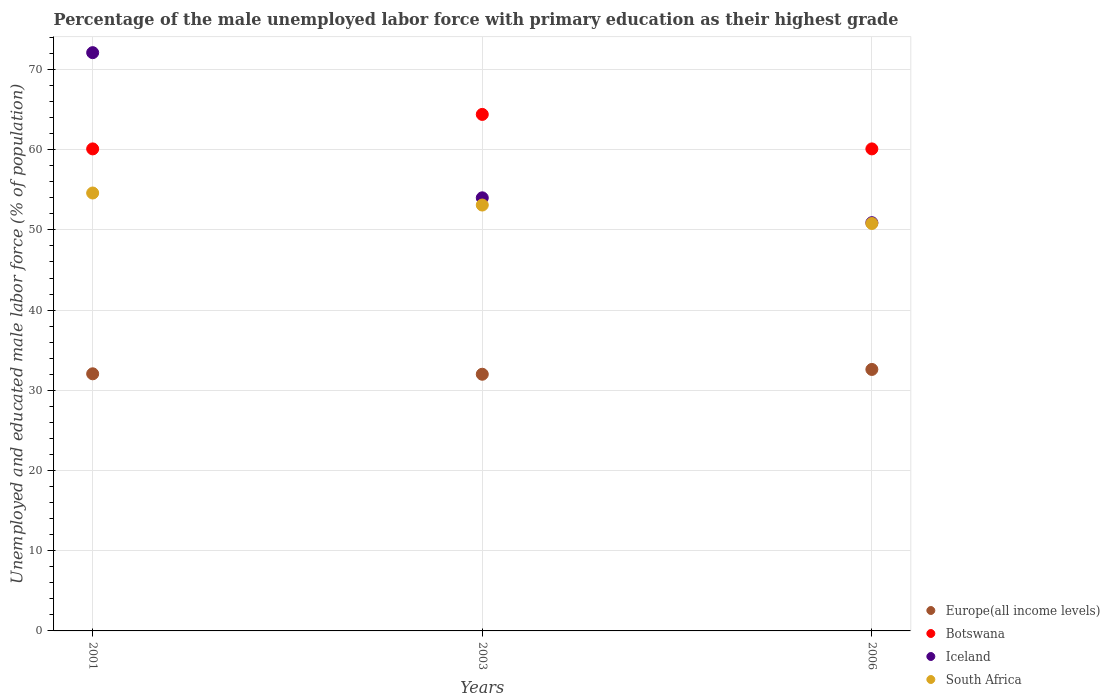How many different coloured dotlines are there?
Your answer should be very brief. 4. Is the number of dotlines equal to the number of legend labels?
Keep it short and to the point. Yes. What is the percentage of the unemployed male labor force with primary education in Botswana in 2001?
Keep it short and to the point. 60.1. Across all years, what is the maximum percentage of the unemployed male labor force with primary education in Botswana?
Give a very brief answer. 64.4. Across all years, what is the minimum percentage of the unemployed male labor force with primary education in South Africa?
Your response must be concise. 50.8. In which year was the percentage of the unemployed male labor force with primary education in South Africa maximum?
Provide a succinct answer. 2001. In which year was the percentage of the unemployed male labor force with primary education in Botswana minimum?
Your response must be concise. 2001. What is the total percentage of the unemployed male labor force with primary education in Europe(all income levels) in the graph?
Make the answer very short. 96.66. What is the difference between the percentage of the unemployed male labor force with primary education in Botswana in 2003 and that in 2006?
Make the answer very short. 4.3. What is the average percentage of the unemployed male labor force with primary education in Iceland per year?
Your response must be concise. 59. In the year 2006, what is the difference between the percentage of the unemployed male labor force with primary education in Botswana and percentage of the unemployed male labor force with primary education in Europe(all income levels)?
Provide a succinct answer. 27.5. In how many years, is the percentage of the unemployed male labor force with primary education in Europe(all income levels) greater than 32 %?
Provide a short and direct response. 3. What is the ratio of the percentage of the unemployed male labor force with primary education in South Africa in 2003 to that in 2006?
Your response must be concise. 1.05. What is the difference between the highest and the second highest percentage of the unemployed male labor force with primary education in Botswana?
Offer a terse response. 4.3. What is the difference between the highest and the lowest percentage of the unemployed male labor force with primary education in Europe(all income levels)?
Your answer should be compact. 0.6. Is the sum of the percentage of the unemployed male labor force with primary education in Botswana in 2001 and 2003 greater than the maximum percentage of the unemployed male labor force with primary education in Iceland across all years?
Your response must be concise. Yes. Is it the case that in every year, the sum of the percentage of the unemployed male labor force with primary education in Botswana and percentage of the unemployed male labor force with primary education in Iceland  is greater than the percentage of the unemployed male labor force with primary education in South Africa?
Your response must be concise. Yes. Is the percentage of the unemployed male labor force with primary education in Iceland strictly greater than the percentage of the unemployed male labor force with primary education in Europe(all income levels) over the years?
Offer a very short reply. Yes. Is the percentage of the unemployed male labor force with primary education in Iceland strictly less than the percentage of the unemployed male labor force with primary education in Botswana over the years?
Provide a short and direct response. No. How many dotlines are there?
Make the answer very short. 4. How many years are there in the graph?
Give a very brief answer. 3. What is the difference between two consecutive major ticks on the Y-axis?
Offer a terse response. 10. Are the values on the major ticks of Y-axis written in scientific E-notation?
Give a very brief answer. No. Does the graph contain grids?
Provide a short and direct response. Yes. Where does the legend appear in the graph?
Ensure brevity in your answer.  Bottom right. How many legend labels are there?
Keep it short and to the point. 4. How are the legend labels stacked?
Your response must be concise. Vertical. What is the title of the graph?
Keep it short and to the point. Percentage of the male unemployed labor force with primary education as their highest grade. What is the label or title of the X-axis?
Make the answer very short. Years. What is the label or title of the Y-axis?
Keep it short and to the point. Unemployed and educated male labor force (% of population). What is the Unemployed and educated male labor force (% of population) in Europe(all income levels) in 2001?
Provide a succinct answer. 32.06. What is the Unemployed and educated male labor force (% of population) in Botswana in 2001?
Your answer should be very brief. 60.1. What is the Unemployed and educated male labor force (% of population) of Iceland in 2001?
Give a very brief answer. 72.1. What is the Unemployed and educated male labor force (% of population) of South Africa in 2001?
Your response must be concise. 54.6. What is the Unemployed and educated male labor force (% of population) of Europe(all income levels) in 2003?
Your answer should be compact. 32. What is the Unemployed and educated male labor force (% of population) in Botswana in 2003?
Offer a very short reply. 64.4. What is the Unemployed and educated male labor force (% of population) of South Africa in 2003?
Your response must be concise. 53.1. What is the Unemployed and educated male labor force (% of population) of Europe(all income levels) in 2006?
Your response must be concise. 32.6. What is the Unemployed and educated male labor force (% of population) of Botswana in 2006?
Keep it short and to the point. 60.1. What is the Unemployed and educated male labor force (% of population) in Iceland in 2006?
Provide a succinct answer. 50.9. What is the Unemployed and educated male labor force (% of population) in South Africa in 2006?
Keep it short and to the point. 50.8. Across all years, what is the maximum Unemployed and educated male labor force (% of population) in Europe(all income levels)?
Provide a short and direct response. 32.6. Across all years, what is the maximum Unemployed and educated male labor force (% of population) of Botswana?
Provide a short and direct response. 64.4. Across all years, what is the maximum Unemployed and educated male labor force (% of population) in Iceland?
Your answer should be very brief. 72.1. Across all years, what is the maximum Unemployed and educated male labor force (% of population) in South Africa?
Keep it short and to the point. 54.6. Across all years, what is the minimum Unemployed and educated male labor force (% of population) in Europe(all income levels)?
Make the answer very short. 32. Across all years, what is the minimum Unemployed and educated male labor force (% of population) of Botswana?
Your response must be concise. 60.1. Across all years, what is the minimum Unemployed and educated male labor force (% of population) of Iceland?
Make the answer very short. 50.9. Across all years, what is the minimum Unemployed and educated male labor force (% of population) in South Africa?
Offer a terse response. 50.8. What is the total Unemployed and educated male labor force (% of population) of Europe(all income levels) in the graph?
Your answer should be compact. 96.66. What is the total Unemployed and educated male labor force (% of population) of Botswana in the graph?
Give a very brief answer. 184.6. What is the total Unemployed and educated male labor force (% of population) in Iceland in the graph?
Your response must be concise. 177. What is the total Unemployed and educated male labor force (% of population) in South Africa in the graph?
Give a very brief answer. 158.5. What is the difference between the Unemployed and educated male labor force (% of population) of Europe(all income levels) in 2001 and that in 2003?
Ensure brevity in your answer.  0.06. What is the difference between the Unemployed and educated male labor force (% of population) in Iceland in 2001 and that in 2003?
Provide a short and direct response. 18.1. What is the difference between the Unemployed and educated male labor force (% of population) of South Africa in 2001 and that in 2003?
Offer a very short reply. 1.5. What is the difference between the Unemployed and educated male labor force (% of population) in Europe(all income levels) in 2001 and that in 2006?
Give a very brief answer. -0.54. What is the difference between the Unemployed and educated male labor force (% of population) of Botswana in 2001 and that in 2006?
Offer a terse response. 0. What is the difference between the Unemployed and educated male labor force (% of population) in Iceland in 2001 and that in 2006?
Offer a terse response. 21.2. What is the difference between the Unemployed and educated male labor force (% of population) in Europe(all income levels) in 2003 and that in 2006?
Ensure brevity in your answer.  -0.6. What is the difference between the Unemployed and educated male labor force (% of population) of Botswana in 2003 and that in 2006?
Offer a very short reply. 4.3. What is the difference between the Unemployed and educated male labor force (% of population) in South Africa in 2003 and that in 2006?
Give a very brief answer. 2.3. What is the difference between the Unemployed and educated male labor force (% of population) of Europe(all income levels) in 2001 and the Unemployed and educated male labor force (% of population) of Botswana in 2003?
Your response must be concise. -32.34. What is the difference between the Unemployed and educated male labor force (% of population) of Europe(all income levels) in 2001 and the Unemployed and educated male labor force (% of population) of Iceland in 2003?
Offer a very short reply. -21.94. What is the difference between the Unemployed and educated male labor force (% of population) of Europe(all income levels) in 2001 and the Unemployed and educated male labor force (% of population) of South Africa in 2003?
Give a very brief answer. -21.04. What is the difference between the Unemployed and educated male labor force (% of population) in Botswana in 2001 and the Unemployed and educated male labor force (% of population) in Iceland in 2003?
Your answer should be compact. 6.1. What is the difference between the Unemployed and educated male labor force (% of population) of Iceland in 2001 and the Unemployed and educated male labor force (% of population) of South Africa in 2003?
Keep it short and to the point. 19. What is the difference between the Unemployed and educated male labor force (% of population) in Europe(all income levels) in 2001 and the Unemployed and educated male labor force (% of population) in Botswana in 2006?
Give a very brief answer. -28.04. What is the difference between the Unemployed and educated male labor force (% of population) in Europe(all income levels) in 2001 and the Unemployed and educated male labor force (% of population) in Iceland in 2006?
Ensure brevity in your answer.  -18.84. What is the difference between the Unemployed and educated male labor force (% of population) of Europe(all income levels) in 2001 and the Unemployed and educated male labor force (% of population) of South Africa in 2006?
Give a very brief answer. -18.74. What is the difference between the Unemployed and educated male labor force (% of population) in Iceland in 2001 and the Unemployed and educated male labor force (% of population) in South Africa in 2006?
Your answer should be compact. 21.3. What is the difference between the Unemployed and educated male labor force (% of population) in Europe(all income levels) in 2003 and the Unemployed and educated male labor force (% of population) in Botswana in 2006?
Your answer should be very brief. -28.1. What is the difference between the Unemployed and educated male labor force (% of population) in Europe(all income levels) in 2003 and the Unemployed and educated male labor force (% of population) in Iceland in 2006?
Keep it short and to the point. -18.9. What is the difference between the Unemployed and educated male labor force (% of population) of Europe(all income levels) in 2003 and the Unemployed and educated male labor force (% of population) of South Africa in 2006?
Give a very brief answer. -18.8. What is the difference between the Unemployed and educated male labor force (% of population) of Iceland in 2003 and the Unemployed and educated male labor force (% of population) of South Africa in 2006?
Give a very brief answer. 3.2. What is the average Unemployed and educated male labor force (% of population) of Europe(all income levels) per year?
Offer a very short reply. 32.22. What is the average Unemployed and educated male labor force (% of population) of Botswana per year?
Offer a terse response. 61.53. What is the average Unemployed and educated male labor force (% of population) in South Africa per year?
Ensure brevity in your answer.  52.83. In the year 2001, what is the difference between the Unemployed and educated male labor force (% of population) in Europe(all income levels) and Unemployed and educated male labor force (% of population) in Botswana?
Give a very brief answer. -28.04. In the year 2001, what is the difference between the Unemployed and educated male labor force (% of population) of Europe(all income levels) and Unemployed and educated male labor force (% of population) of Iceland?
Your answer should be compact. -40.04. In the year 2001, what is the difference between the Unemployed and educated male labor force (% of population) in Europe(all income levels) and Unemployed and educated male labor force (% of population) in South Africa?
Your response must be concise. -22.54. In the year 2001, what is the difference between the Unemployed and educated male labor force (% of population) in Botswana and Unemployed and educated male labor force (% of population) in South Africa?
Your answer should be very brief. 5.5. In the year 2001, what is the difference between the Unemployed and educated male labor force (% of population) in Iceland and Unemployed and educated male labor force (% of population) in South Africa?
Your answer should be very brief. 17.5. In the year 2003, what is the difference between the Unemployed and educated male labor force (% of population) in Europe(all income levels) and Unemployed and educated male labor force (% of population) in Botswana?
Keep it short and to the point. -32.4. In the year 2003, what is the difference between the Unemployed and educated male labor force (% of population) of Europe(all income levels) and Unemployed and educated male labor force (% of population) of Iceland?
Ensure brevity in your answer.  -22. In the year 2003, what is the difference between the Unemployed and educated male labor force (% of population) in Europe(all income levels) and Unemployed and educated male labor force (% of population) in South Africa?
Provide a short and direct response. -21.1. In the year 2003, what is the difference between the Unemployed and educated male labor force (% of population) of Botswana and Unemployed and educated male labor force (% of population) of Iceland?
Your answer should be very brief. 10.4. In the year 2003, what is the difference between the Unemployed and educated male labor force (% of population) in Botswana and Unemployed and educated male labor force (% of population) in South Africa?
Make the answer very short. 11.3. In the year 2003, what is the difference between the Unemployed and educated male labor force (% of population) of Iceland and Unemployed and educated male labor force (% of population) of South Africa?
Make the answer very short. 0.9. In the year 2006, what is the difference between the Unemployed and educated male labor force (% of population) of Europe(all income levels) and Unemployed and educated male labor force (% of population) of Botswana?
Provide a short and direct response. -27.5. In the year 2006, what is the difference between the Unemployed and educated male labor force (% of population) in Europe(all income levels) and Unemployed and educated male labor force (% of population) in Iceland?
Your answer should be very brief. -18.3. In the year 2006, what is the difference between the Unemployed and educated male labor force (% of population) in Europe(all income levels) and Unemployed and educated male labor force (% of population) in South Africa?
Give a very brief answer. -18.2. In the year 2006, what is the difference between the Unemployed and educated male labor force (% of population) of Botswana and Unemployed and educated male labor force (% of population) of Iceland?
Provide a succinct answer. 9.2. In the year 2006, what is the difference between the Unemployed and educated male labor force (% of population) in Botswana and Unemployed and educated male labor force (% of population) in South Africa?
Provide a succinct answer. 9.3. What is the ratio of the Unemployed and educated male labor force (% of population) of Europe(all income levels) in 2001 to that in 2003?
Keep it short and to the point. 1. What is the ratio of the Unemployed and educated male labor force (% of population) of Botswana in 2001 to that in 2003?
Ensure brevity in your answer.  0.93. What is the ratio of the Unemployed and educated male labor force (% of population) of Iceland in 2001 to that in 2003?
Give a very brief answer. 1.34. What is the ratio of the Unemployed and educated male labor force (% of population) in South Africa in 2001 to that in 2003?
Keep it short and to the point. 1.03. What is the ratio of the Unemployed and educated male labor force (% of population) in Europe(all income levels) in 2001 to that in 2006?
Offer a very short reply. 0.98. What is the ratio of the Unemployed and educated male labor force (% of population) in Botswana in 2001 to that in 2006?
Ensure brevity in your answer.  1. What is the ratio of the Unemployed and educated male labor force (% of population) in Iceland in 2001 to that in 2006?
Ensure brevity in your answer.  1.42. What is the ratio of the Unemployed and educated male labor force (% of population) of South Africa in 2001 to that in 2006?
Your answer should be compact. 1.07. What is the ratio of the Unemployed and educated male labor force (% of population) in Europe(all income levels) in 2003 to that in 2006?
Make the answer very short. 0.98. What is the ratio of the Unemployed and educated male labor force (% of population) of Botswana in 2003 to that in 2006?
Give a very brief answer. 1.07. What is the ratio of the Unemployed and educated male labor force (% of population) in Iceland in 2003 to that in 2006?
Your answer should be very brief. 1.06. What is the ratio of the Unemployed and educated male labor force (% of population) of South Africa in 2003 to that in 2006?
Provide a succinct answer. 1.05. What is the difference between the highest and the second highest Unemployed and educated male labor force (% of population) in Europe(all income levels)?
Provide a short and direct response. 0.54. What is the difference between the highest and the second highest Unemployed and educated male labor force (% of population) in Botswana?
Keep it short and to the point. 4.3. What is the difference between the highest and the lowest Unemployed and educated male labor force (% of population) in Europe(all income levels)?
Offer a terse response. 0.6. What is the difference between the highest and the lowest Unemployed and educated male labor force (% of population) in Botswana?
Ensure brevity in your answer.  4.3. What is the difference between the highest and the lowest Unemployed and educated male labor force (% of population) of Iceland?
Your response must be concise. 21.2. 